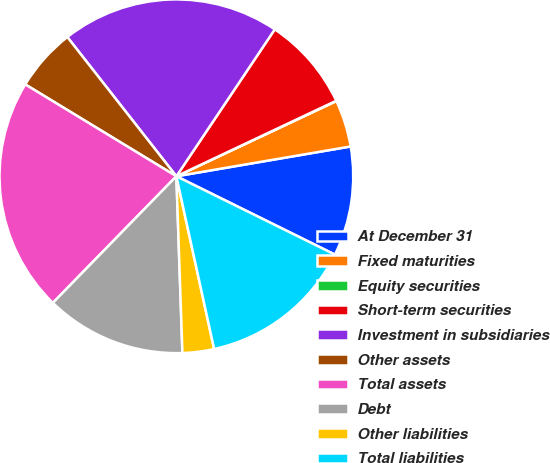<chart> <loc_0><loc_0><loc_500><loc_500><pie_chart><fcel>At December 31<fcel>Fixed maturities<fcel>Equity securities<fcel>Short-term securities<fcel>Investment in subsidiaries<fcel>Other assets<fcel>Total assets<fcel>Debt<fcel>Other liabilities<fcel>Total liabilities<nl><fcel>10.0%<fcel>4.3%<fcel>0.03%<fcel>8.58%<fcel>19.97%<fcel>5.73%<fcel>21.39%<fcel>12.85%<fcel>2.88%<fcel>14.27%<nl></chart> 